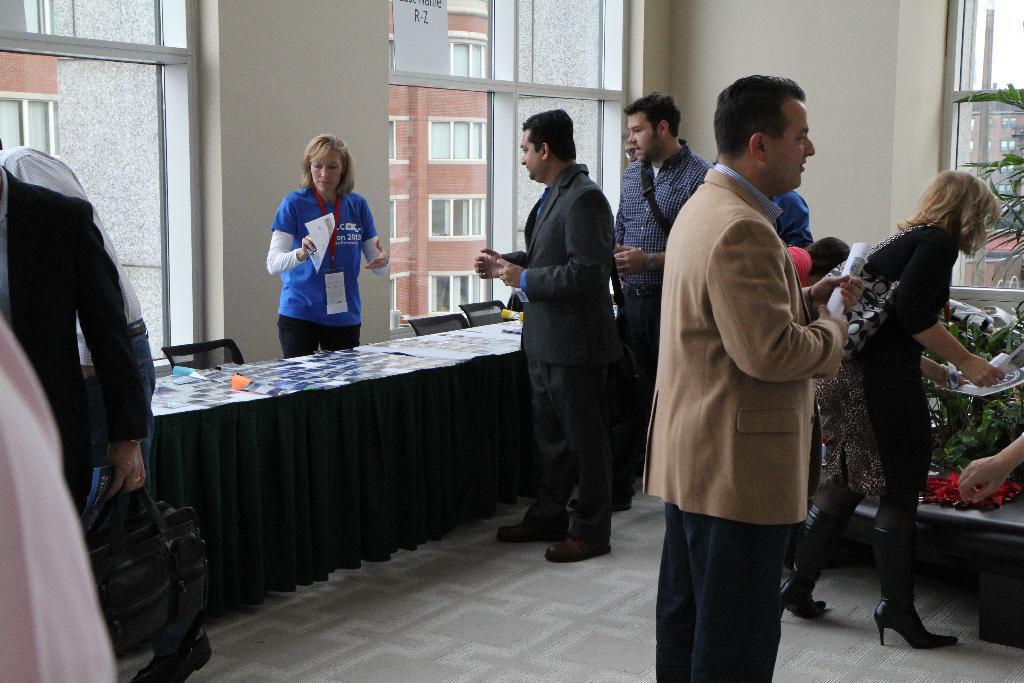Describe this image in one or two sentences. In this image there are a few people standing, in front of them there is a table with three papers on it, behind the table there is a woman and there are a few chairs, behind the woman there is wall, beside the wall there is a glass window. 